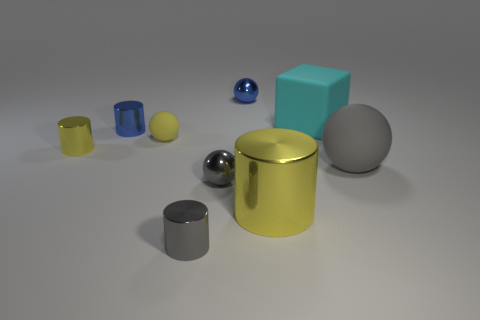Is there anything else that is the same shape as the big cyan matte object?
Offer a very short reply. No. There is a metallic thing that is the same size as the cyan block; what is its color?
Give a very brief answer. Yellow. Is there a tiny ball that is in front of the shiny sphere behind the large cube?
Offer a very short reply. Yes. How many cylinders are either metal things or cyan rubber things?
Offer a terse response. 4. What is the size of the yellow cylinder to the right of the tiny metal ball behind the yellow metal cylinder that is left of the small blue cylinder?
Keep it short and to the point. Large. There is a big yellow shiny object; are there any gray metal balls in front of it?
Give a very brief answer. No. What is the shape of the small shiny object that is the same color as the large metal object?
Offer a terse response. Cylinder. How many things are either yellow metallic cylinders that are to the left of the large metal cylinder or tiny blue objects?
Ensure brevity in your answer.  3. What size is the gray ball that is the same material as the block?
Your answer should be very brief. Large. Is the size of the blue cylinder the same as the matte object that is in front of the small yellow metal cylinder?
Your answer should be compact. No. 